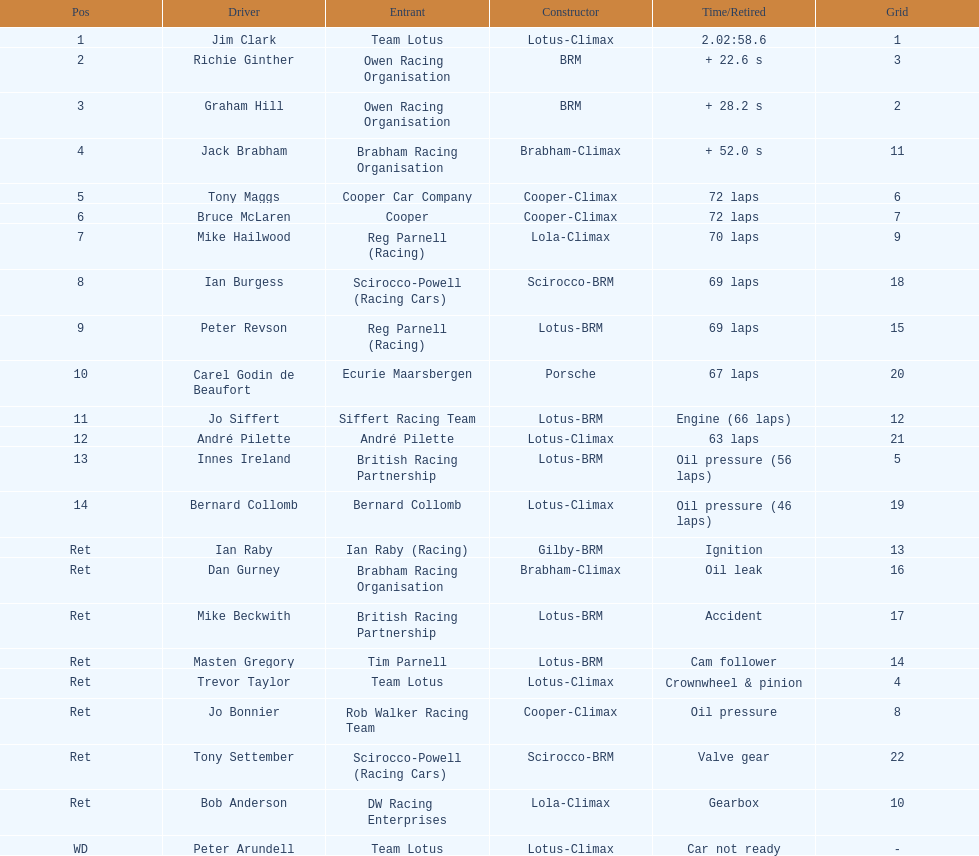Which driver had the top performance in a cooper-climax car? Tony Maggs. 